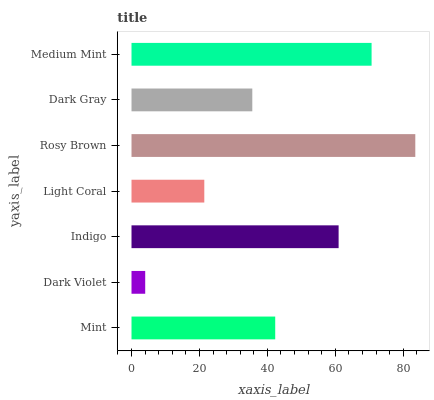Is Dark Violet the minimum?
Answer yes or no. Yes. Is Rosy Brown the maximum?
Answer yes or no. Yes. Is Indigo the minimum?
Answer yes or no. No. Is Indigo the maximum?
Answer yes or no. No. Is Indigo greater than Dark Violet?
Answer yes or no. Yes. Is Dark Violet less than Indigo?
Answer yes or no. Yes. Is Dark Violet greater than Indigo?
Answer yes or no. No. Is Indigo less than Dark Violet?
Answer yes or no. No. Is Mint the high median?
Answer yes or no. Yes. Is Mint the low median?
Answer yes or no. Yes. Is Indigo the high median?
Answer yes or no. No. Is Light Coral the low median?
Answer yes or no. No. 